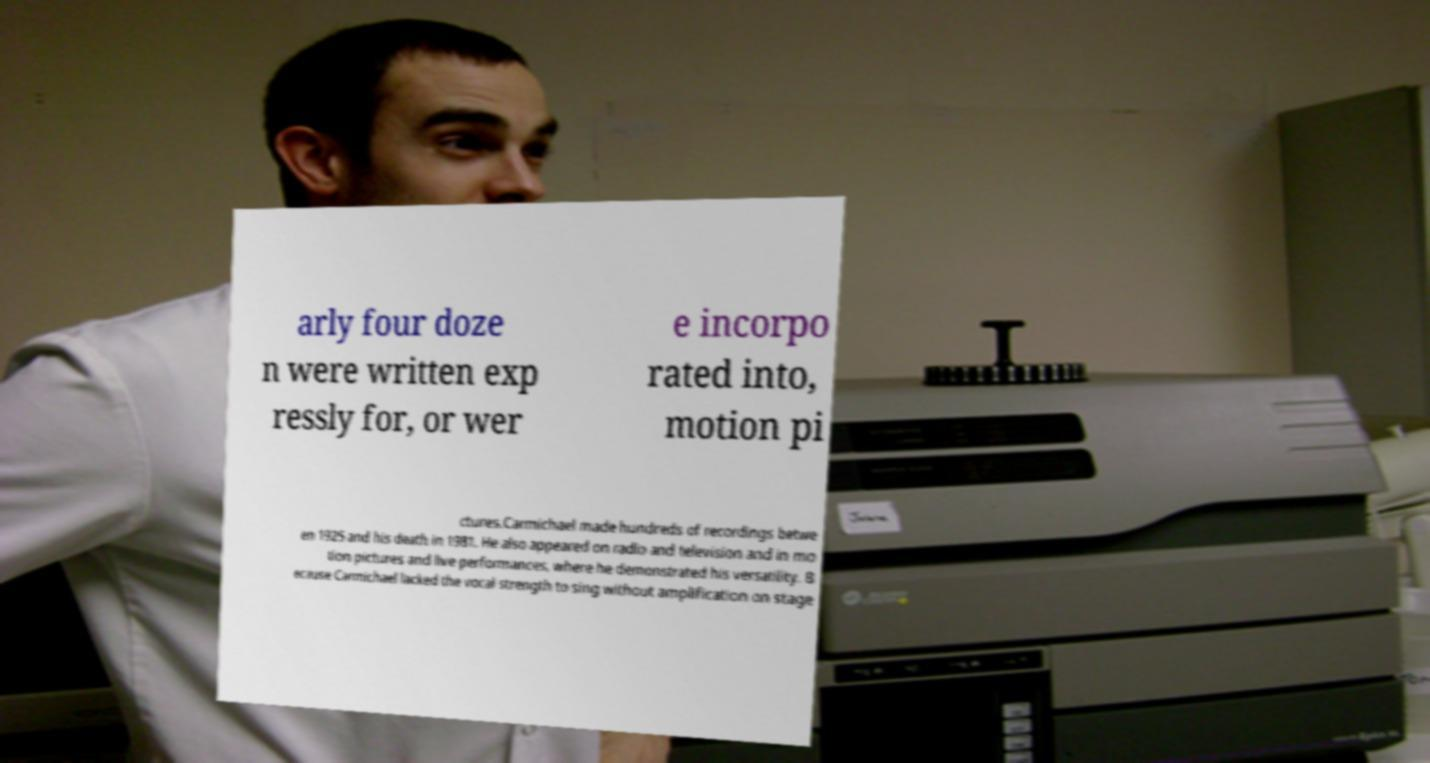For documentation purposes, I need the text within this image transcribed. Could you provide that? arly four doze n were written exp ressly for, or wer e incorpo rated into, motion pi ctures.Carmichael made hundreds of recordings betwe en 1925 and his death in 1981. He also appeared on radio and television and in mo tion pictures and live performances, where he demonstrated his versatility. B ecause Carmichael lacked the vocal strength to sing without amplification on stage 